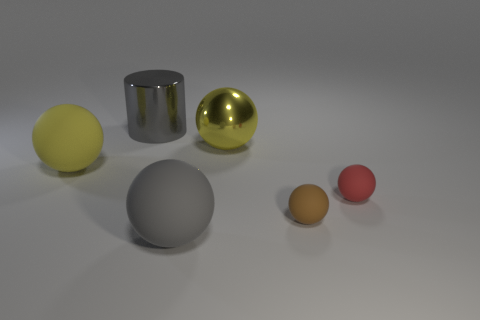Is the number of red objects on the left side of the big gray rubber object the same as the number of large yellow metal things that are behind the red object?
Give a very brief answer. No. There is a shiny thing that is in front of the big cylinder; does it have the same shape as the yellow thing that is to the left of the large gray cylinder?
Your response must be concise. Yes. Are there any other things that are the same shape as the gray metallic thing?
Make the answer very short. No. The tiny brown object that is the same material as the small red thing is what shape?
Ensure brevity in your answer.  Sphere. Are there the same number of large yellow rubber objects that are right of the large gray matte ball and tiny cyan rubber spheres?
Make the answer very short. Yes. Does the object to the left of the big gray cylinder have the same material as the large gray object behind the red matte ball?
Make the answer very short. No. There is a tiny matte thing that is on the right side of the small brown rubber thing in front of the red ball; what shape is it?
Offer a very short reply. Sphere. There is a object that is made of the same material as the cylinder; what color is it?
Provide a succinct answer. Yellow. What is the shape of the other shiny object that is the same size as the yellow metallic thing?
Ensure brevity in your answer.  Cylinder. The brown rubber thing is what size?
Make the answer very short. Small. 